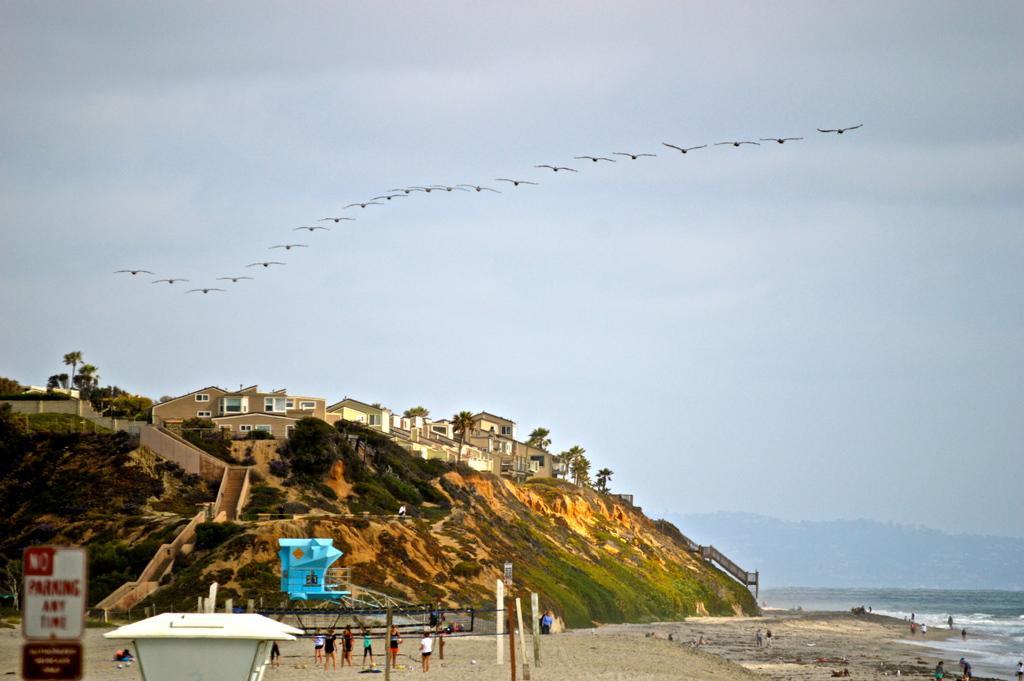In one or two sentences, can you explain what this image depicts? The picture is taken on the beach. In the foreground of the picture there are people, hoardings and sand. In the center the picture there are buildings, trees on a hill. On the right there are people, water and hill. In the center of the picture there are birds flying. Sky is cloudy. 